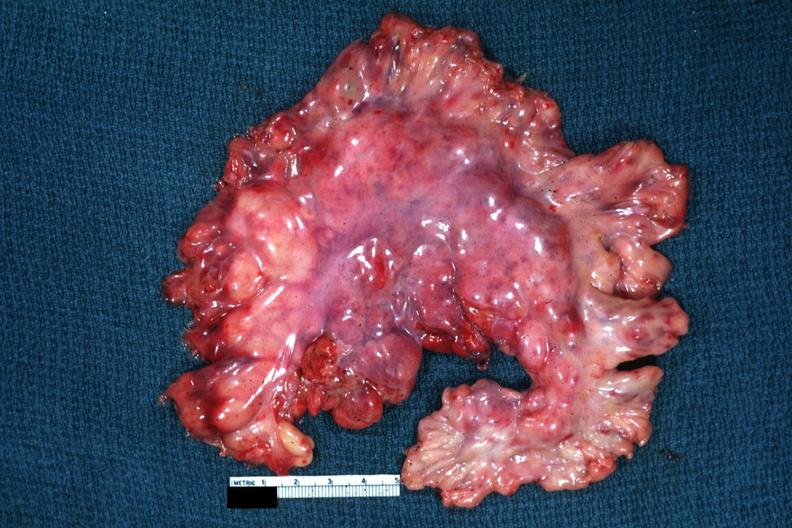what does this image show?
Answer the question using a single word or phrase. Fair to good example of mesentery containing grossly enlarged nodes 